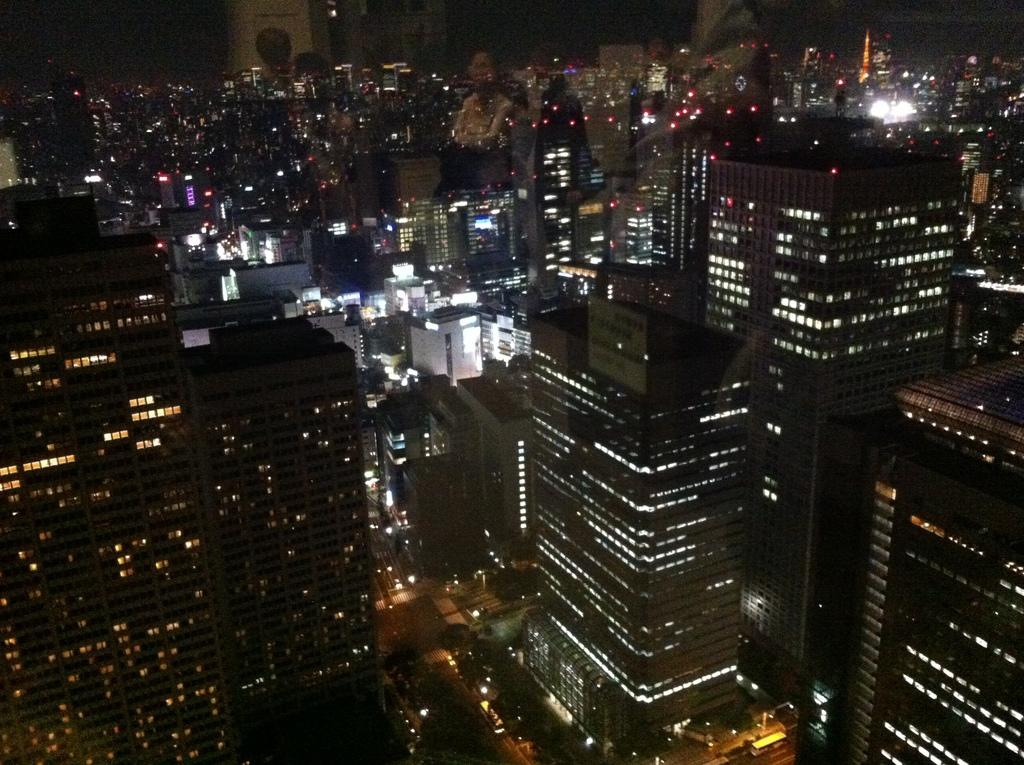What object is present in the image that contains a view of many buildings? The image contains a glass through which many buildings are visible. What type of illumination is present in the image? Lights are present in the image. What type of natural vegetation can be seen in the image? Trees are visible in the image. What type of man-made structure can be seen in the image? A road is visible in the image. What part of the natural environment is visible in the image? The sky is visible in the image. Are there any reflections visible on the glass in the image? Yes, reflections of persons are present on the glass. Can you see a trail of ants on the glass in the image? There is no trail of ants visible on the glass in the image. Are there any bees buzzing around the trees in the image? There is no mention of bees in the image, and the focus is on the glass and the view through it. Is there a farm visible in the image? There is no mention of a farm in the image; the focus is on the glass and the view through it, which includes buildings, trees, a road, and the sky. 